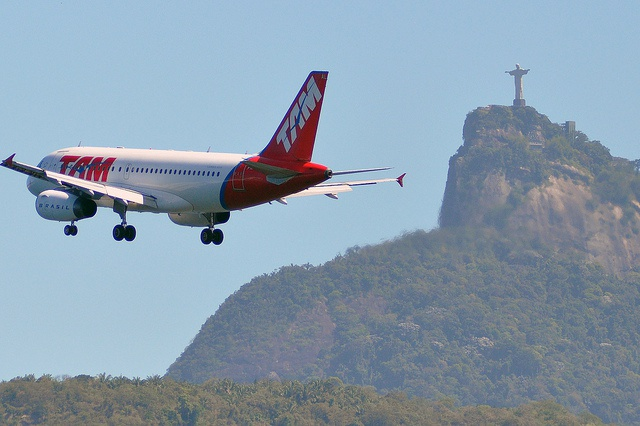Describe the objects in this image and their specific colors. I can see a airplane in lightblue, black, lightgray, maroon, and gray tones in this image. 